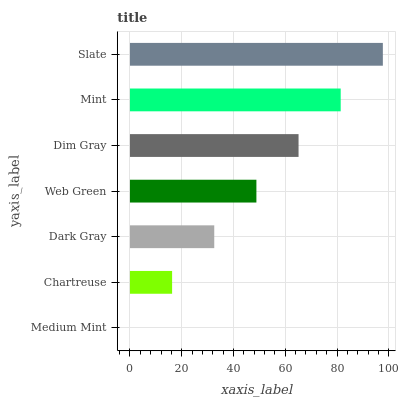Is Medium Mint the minimum?
Answer yes or no. Yes. Is Slate the maximum?
Answer yes or no. Yes. Is Chartreuse the minimum?
Answer yes or no. No. Is Chartreuse the maximum?
Answer yes or no. No. Is Chartreuse greater than Medium Mint?
Answer yes or no. Yes. Is Medium Mint less than Chartreuse?
Answer yes or no. Yes. Is Medium Mint greater than Chartreuse?
Answer yes or no. No. Is Chartreuse less than Medium Mint?
Answer yes or no. No. Is Web Green the high median?
Answer yes or no. Yes. Is Web Green the low median?
Answer yes or no. Yes. Is Chartreuse the high median?
Answer yes or no. No. Is Dark Gray the low median?
Answer yes or no. No. 